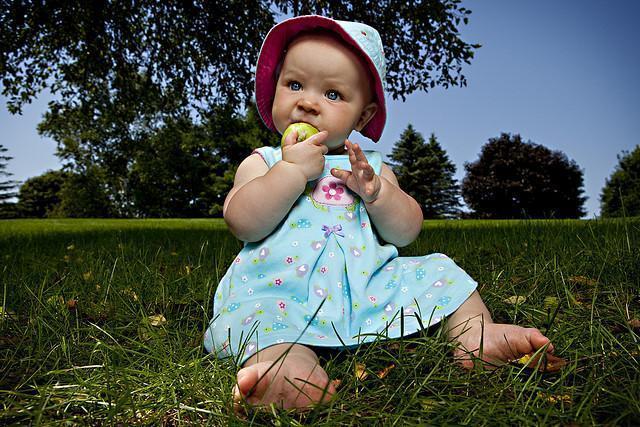How many giraffes are leaning down to drink?
Give a very brief answer. 0. 